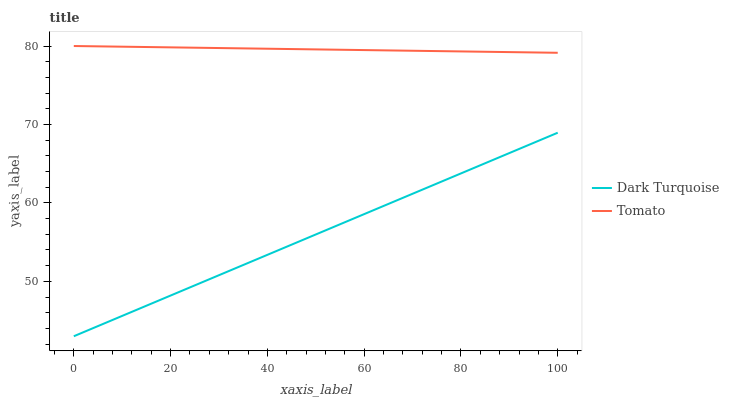Does Dark Turquoise have the minimum area under the curve?
Answer yes or no. Yes. Does Tomato have the maximum area under the curve?
Answer yes or no. Yes. Does Dark Turquoise have the maximum area under the curve?
Answer yes or no. No. Is Tomato the smoothest?
Answer yes or no. Yes. Is Dark Turquoise the roughest?
Answer yes or no. Yes. Is Dark Turquoise the smoothest?
Answer yes or no. No. Does Tomato have the highest value?
Answer yes or no. Yes. Does Dark Turquoise have the highest value?
Answer yes or no. No. Is Dark Turquoise less than Tomato?
Answer yes or no. Yes. Is Tomato greater than Dark Turquoise?
Answer yes or no. Yes. Does Dark Turquoise intersect Tomato?
Answer yes or no. No. 